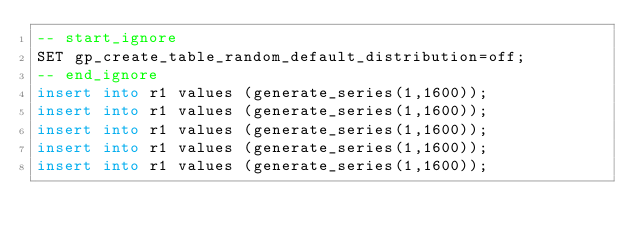<code> <loc_0><loc_0><loc_500><loc_500><_SQL_>-- start_ignore
SET gp_create_table_random_default_distribution=off;
-- end_ignore
insert into r1 values (generate_series(1,1600));
insert into r1 values (generate_series(1,1600));
insert into r1 values (generate_series(1,1600));
insert into r1 values (generate_series(1,1600));
insert into r1 values (generate_series(1,1600));</code> 